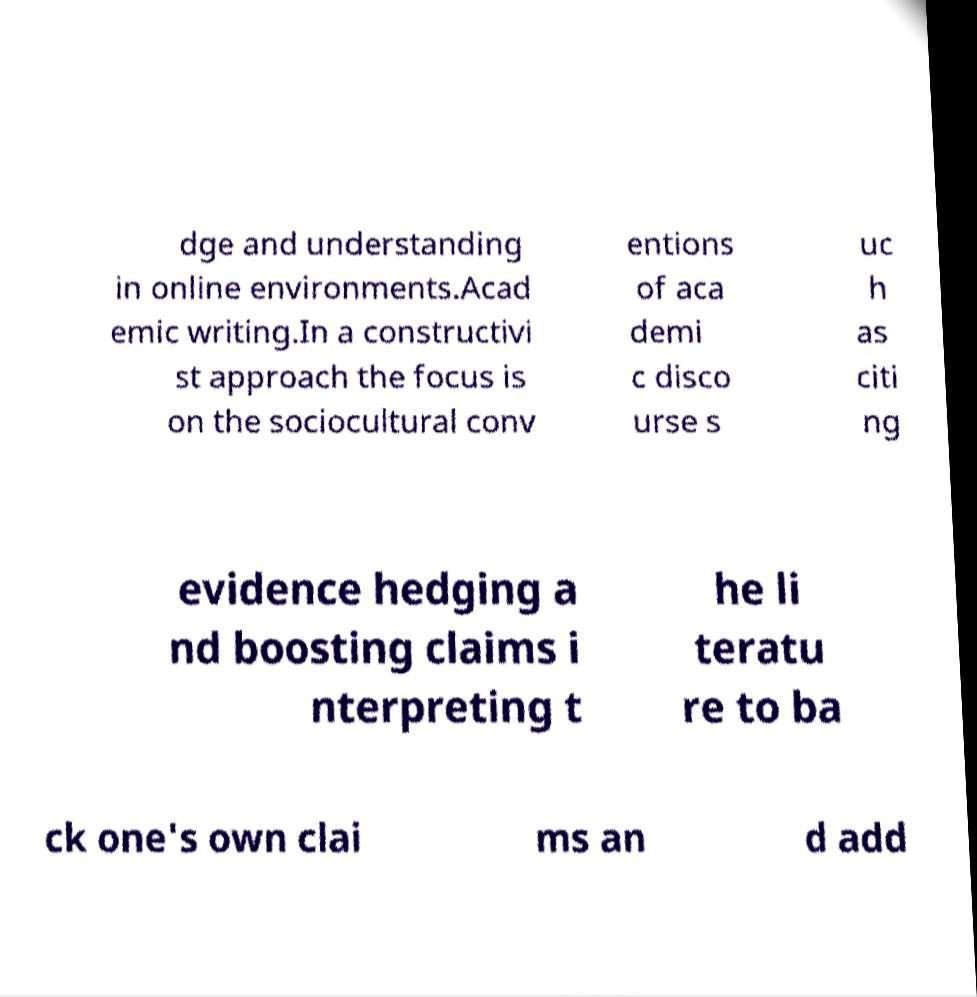Can you read and provide the text displayed in the image?This photo seems to have some interesting text. Can you extract and type it out for me? dge and understanding in online environments.Acad emic writing.In a constructivi st approach the focus is on the sociocultural conv entions of aca demi c disco urse s uc h as citi ng evidence hedging a nd boosting claims i nterpreting t he li teratu re to ba ck one's own clai ms an d add 